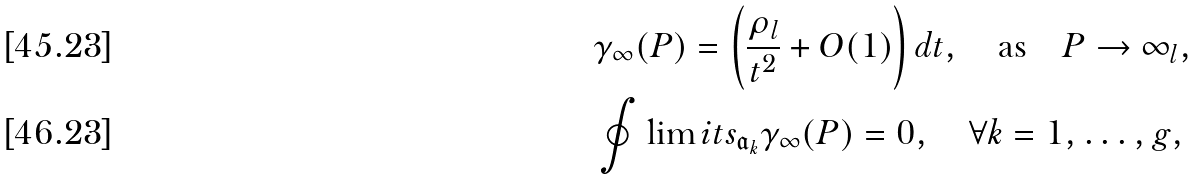<formula> <loc_0><loc_0><loc_500><loc_500>& \gamma _ { \infty } ( P ) = \left ( \frac { \rho _ { l } } { t ^ { 2 } } + O ( 1 ) \right ) { d } t , \quad \text {as} \quad P \rightarrow \infty _ { l } , \\ & \oint \lim i t s _ { \mathfrak { a } _ { k } } \gamma _ { \infty } ( P ) = 0 , \quad \forall k = 1 , \dots , g ,</formula> 